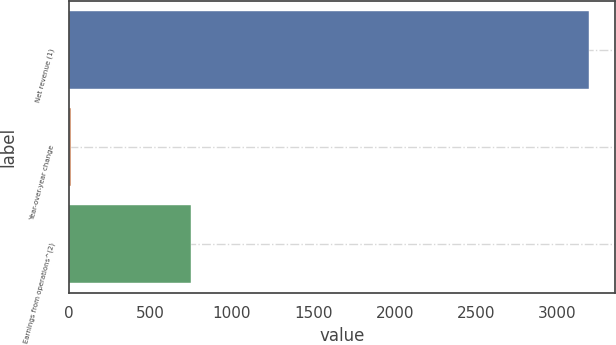<chart> <loc_0><loc_0><loc_500><loc_500><bar_chart><fcel>Net revenue (1)<fcel>Year-over-year change<fcel>Earnings from operations^(2)<nl><fcel>3195<fcel>11.8<fcel>749<nl></chart> 